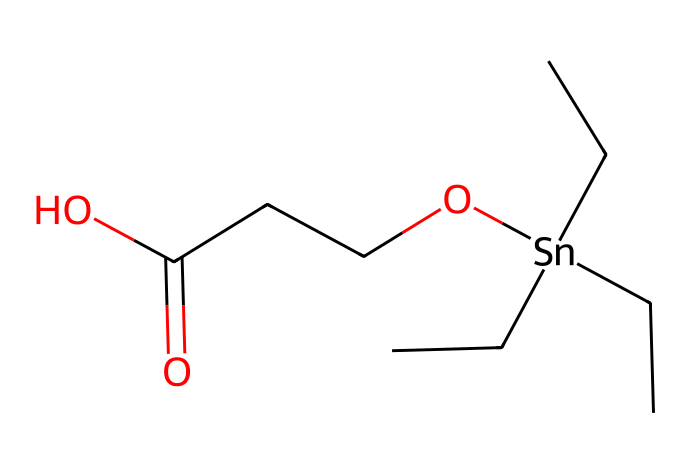how many carbon atoms are in the compound? By analyzing the SMILES representation, we count the "C" characters before the "Sn" (tin) symbol. There are three "CC" groups connected to the tin and an additional "C" in the chain leading to the ester functional group, making a total of 5 carbon atoms.
Answer: 9 what is the functional group present in this compound? The SMILES includes "O" followed by "CCC(=O)O", which indicates the presence of a carboxylic acid group (-COOH). Specifically, the structure shows a carbonyl (C=O) and an alcohol (-OH) connected to the same carbon.
Answer: carboxylic acid what is the coordination number of the tin atom? The tin atom is surrounded by three carbon groups and one oxygen atom from the carboxylic acid. This results in a total of four coordinate groups attached to the tin.
Answer: 4 what type of organometallic compound is represented? The compound contains tin bonded to carbon atoms, typical for organotin compounds, which are characterized by tin's bonding with organic groups. The presence of metal and carbon defines it as an organotin compound.
Answer: organotin which part of the molecule is responsible for its anti-fouling properties? The organotin moiety is known for exhibiting anti-fouling characteristics due to the presence of tin which affects marine organisms' ability to attach. The overall structure, including the ester and carbon chains, contributes to its performance in coatings as well.
Answer: organotin moiety how many oxygen atoms are present in the compound? The SMILES representation shows two oxygen atoms in the carboxylic acid (-COOH) and one in the ester, making a total of three oxygen atoms in the structure.
Answer: 3 